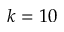Convert formula to latex. <formula><loc_0><loc_0><loc_500><loc_500>k = 1 0</formula> 